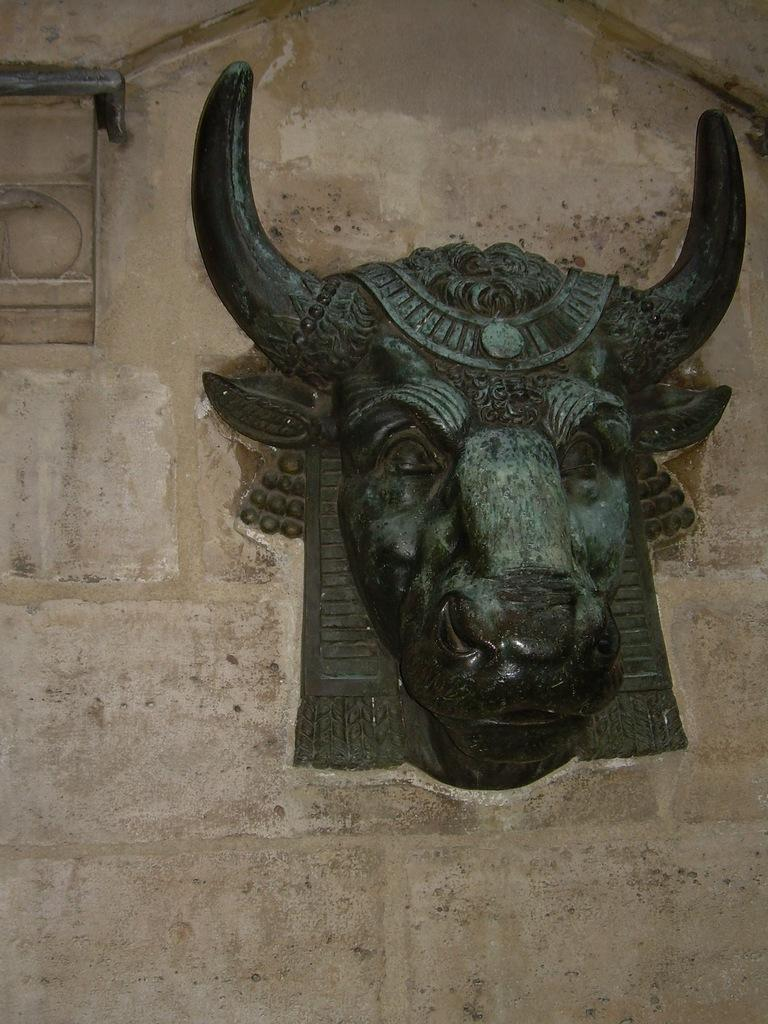What type of object is depicted in the image? There is a sculpture of an animal head in the image. Where is the sculpture located? The sculpture is on the wall. What type of operation is being performed on the animal head sculpture in the image? There is no operation being performed on the animal head sculpture in the image; it is simply displayed on the wall. 